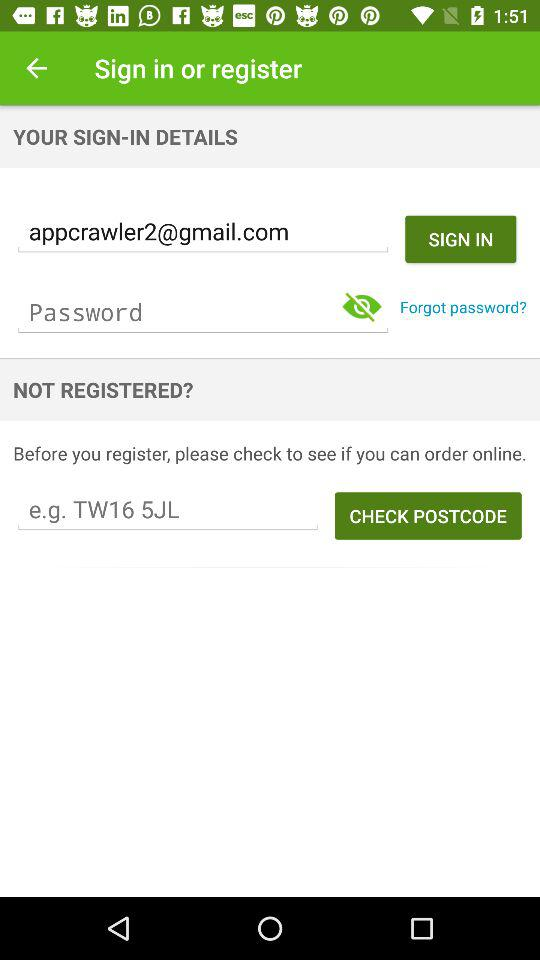What is the email address? The email address is appcrawler2@gmail.com. 